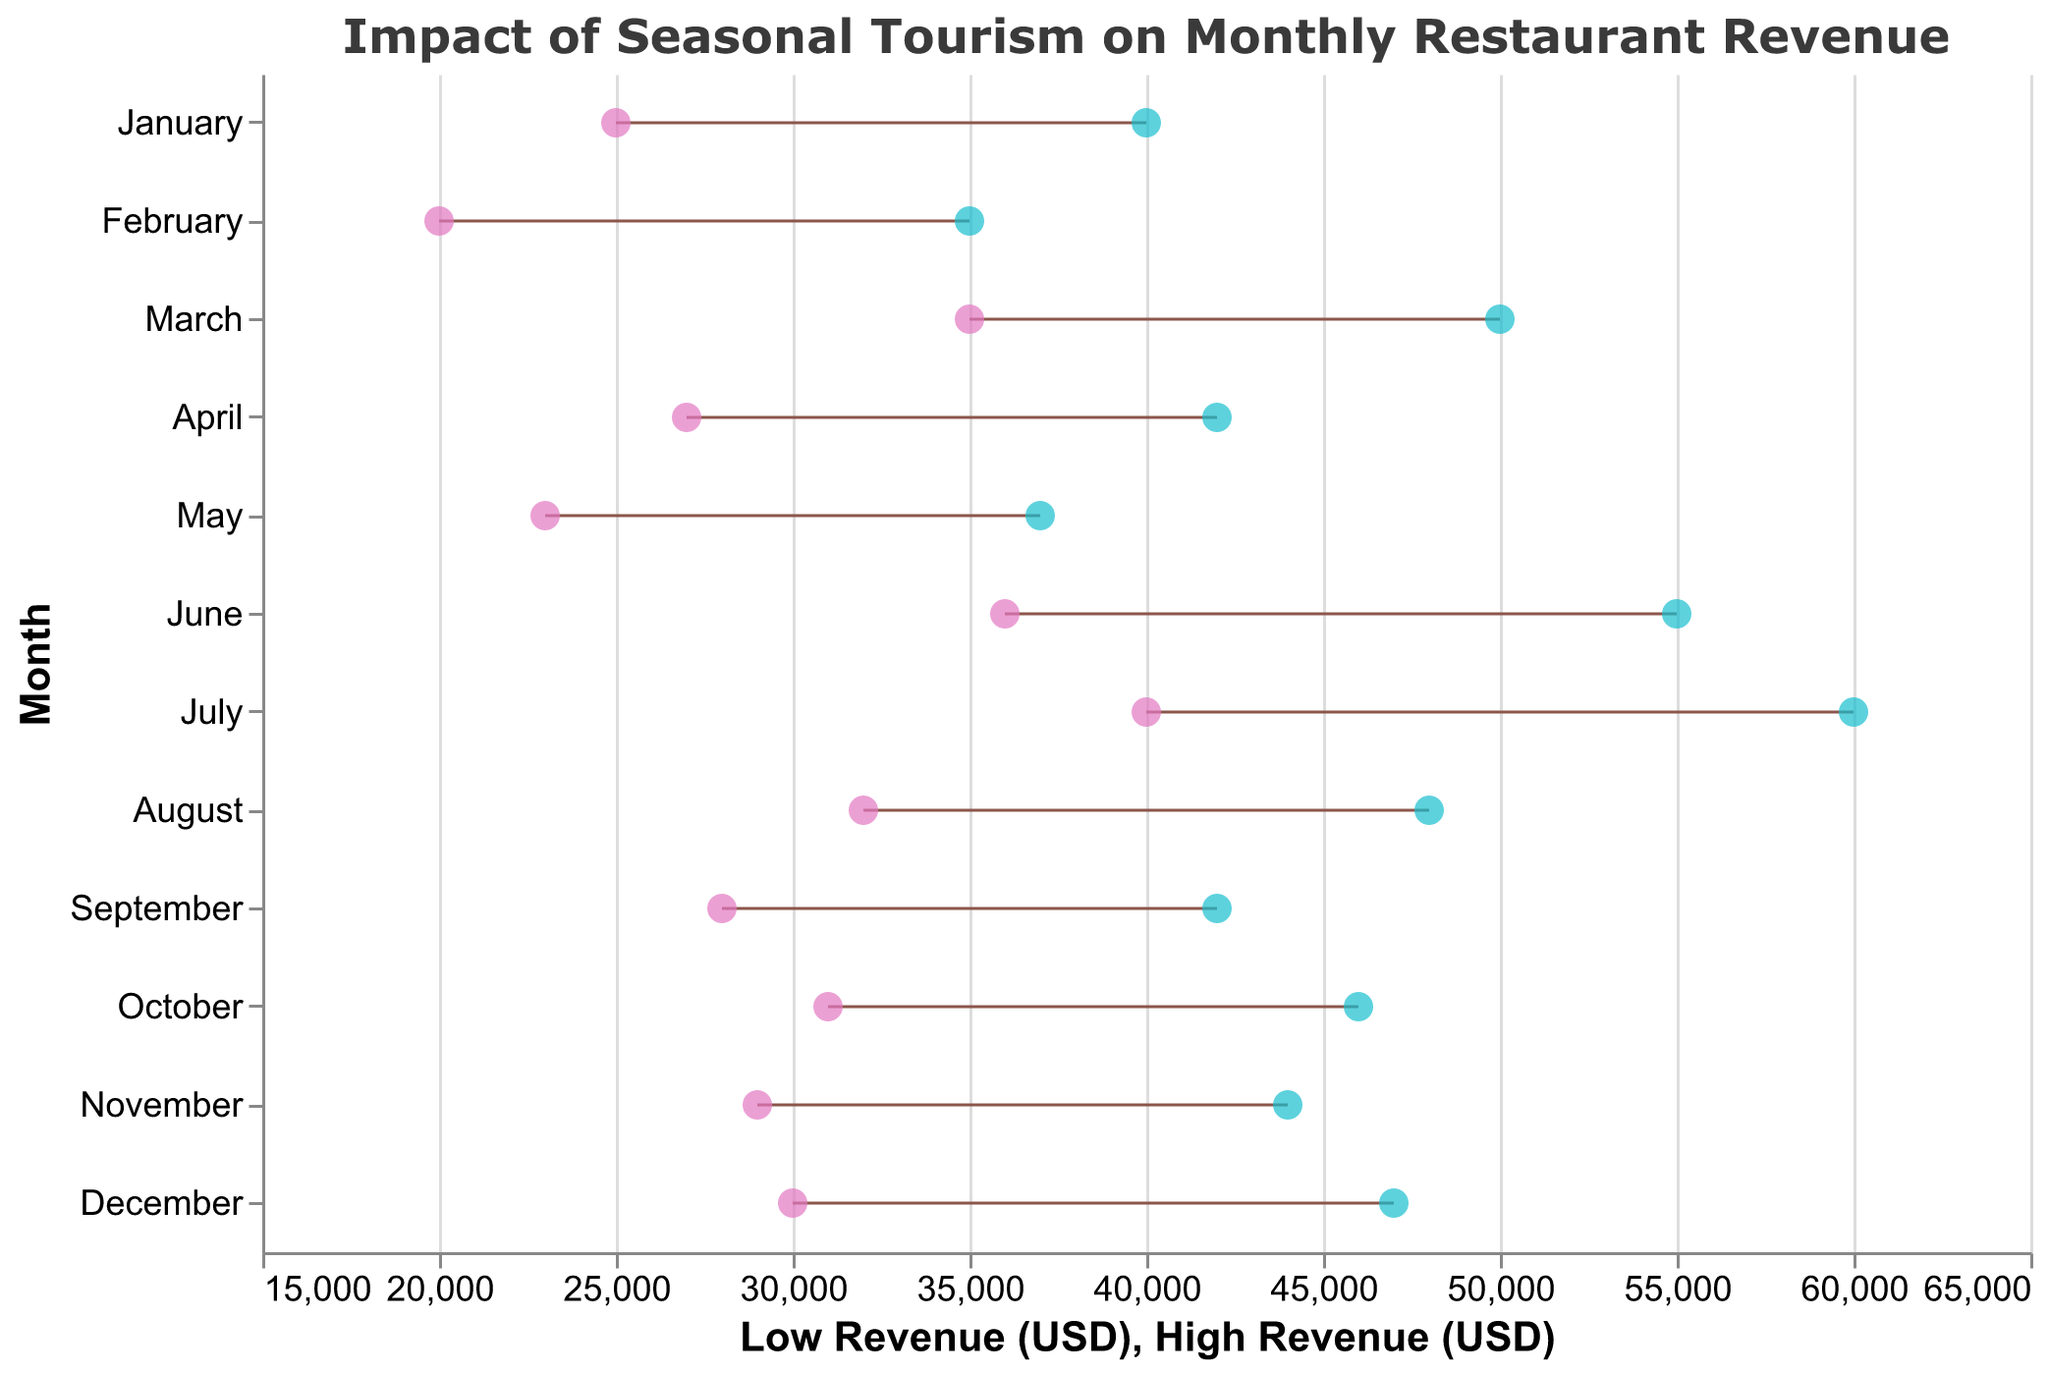How many months show restaurant revenue data? The y-axis in the plot lists the months for which revenue data is provided. By counting these, we can determine the number of months.
Answer: 12 Which month has the highest possible revenue for any restaurant? By observing the points on the x-axis representing the high revenue values, July (Sunset Grill, Santa Monica) has the highest possible revenue at $60,000.
Answer: July What is the range of revenue for Lakehouse Restaurant in June? The range is determined by subtracting the low revenue value from the high revenue value for June. For Lakehouse Restaurant, South Lake Tahoe, the range is $55,000 - $36,000.
Answer: $19,000 Which restaurant in Boulder has recorded the revenue data? By hovering over or referring to the tooltip provided for the month of September, we can identify the restaurant in Boulder as Green Valley Tavern.
Answer: Green Valley Tavern Compare the revenue spread between Seaside Bistro in February and Christmas Lodge Restaurant in December. Which one has a wider range? The revenue range for Seaside Bistro in February is $35,000 - $20,000 = $15,000. The range for Christmas Lodge Restaurant in December is $47,000 - $30,000 = $17,000. Since $17,000 > $15,000, December has a wider spread.
Answer: December What is the median high revenue value across all months? To find the median, we first list the high revenue values in ascending order: $35,000, $37,000, $40,000, $42,000, $42000, $44,000, $46,000, $47,000, $48,000, $50,000, $55,000, $60,000. With 12 values, the median is the average of the 6th and 7th values: ($44,000 + $46,000) / 2.
Answer: $45,000 Do any restaurants show a lower revenue value below $25,000? Scanning the low revenue points on the x-axis, Seaside Bistro in February has the lowest revenue which is $20,000, below $25,000.
Answer: Yes Identify the month with the smallest difference between the low and high revenue. Calculate the revenue range for each month and find the smallest: 
- January: $40,000 - $25,000 = $15,000 
- February: $35,000 - $20,000 = $15,000 
- March: $50,000 - $35,000 = $15,000 
- April: $42,000 - $27,000 = $15,000 
- May: $37,000 - $23,000 = $14,000 (smallest) 
- June: $55,000 - $36,000 = $19,000 
- July: $60,000 - $40,000 = $20,000 
- August: $48,000 - $32,000 = $16,000 
- September: $42,000 - $28,000 = $14,000 (smallest) 
- October: $46,000 - $31,000 = $15,000 
- November: $44,000 - $29,000 = $15,000 
- December: $47,000 - $30,000 = $17,000 
Both May and September have the smallest difference of $14,000.
Answer: May and September 